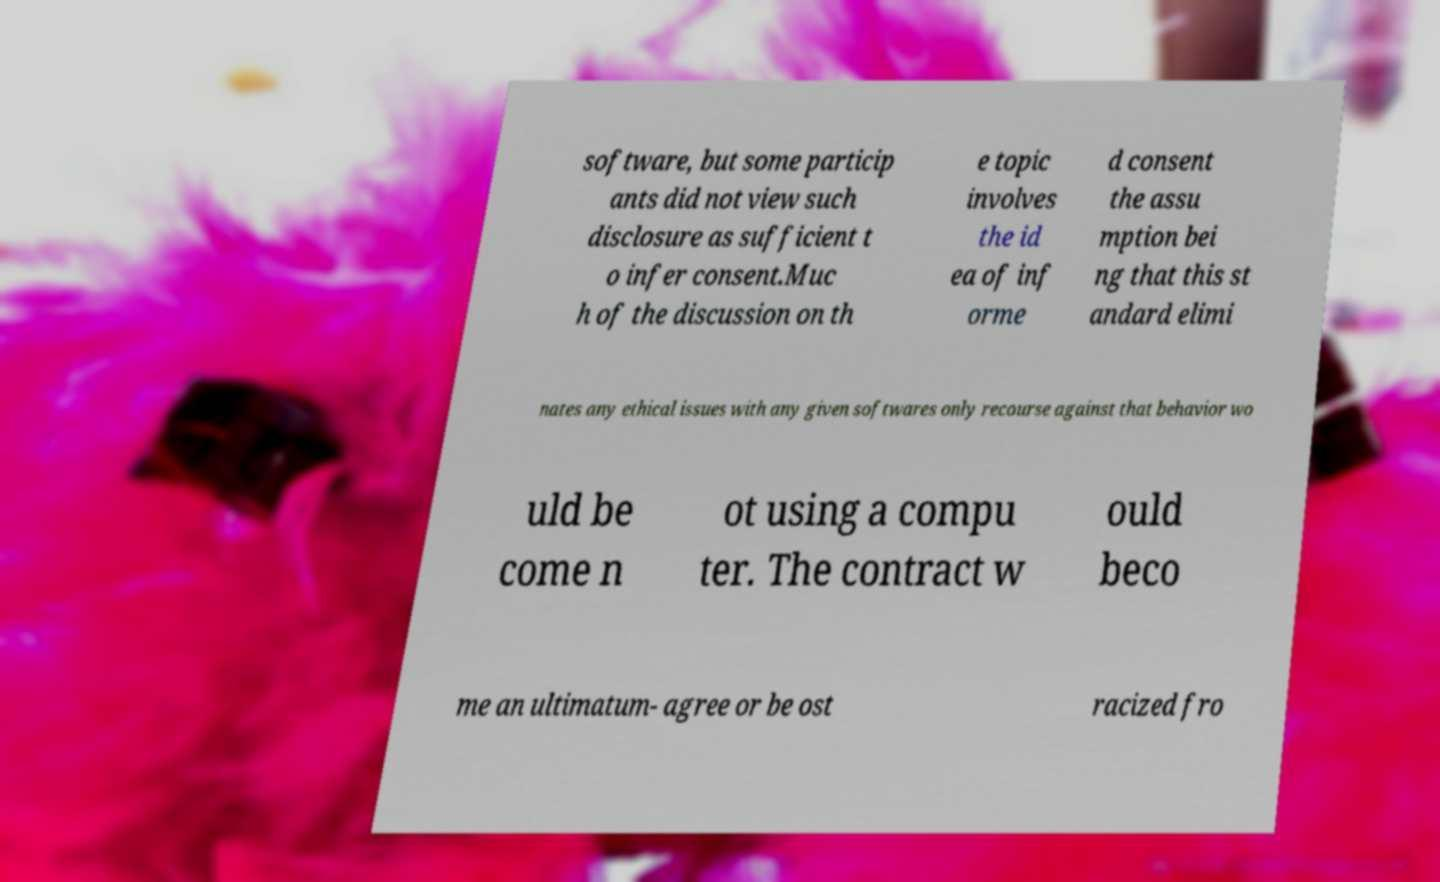Can you accurately transcribe the text from the provided image for me? software, but some particip ants did not view such disclosure as sufficient t o infer consent.Muc h of the discussion on th e topic involves the id ea of inf orme d consent the assu mption bei ng that this st andard elimi nates any ethical issues with any given softwares only recourse against that behavior wo uld be come n ot using a compu ter. The contract w ould beco me an ultimatum- agree or be ost racized fro 